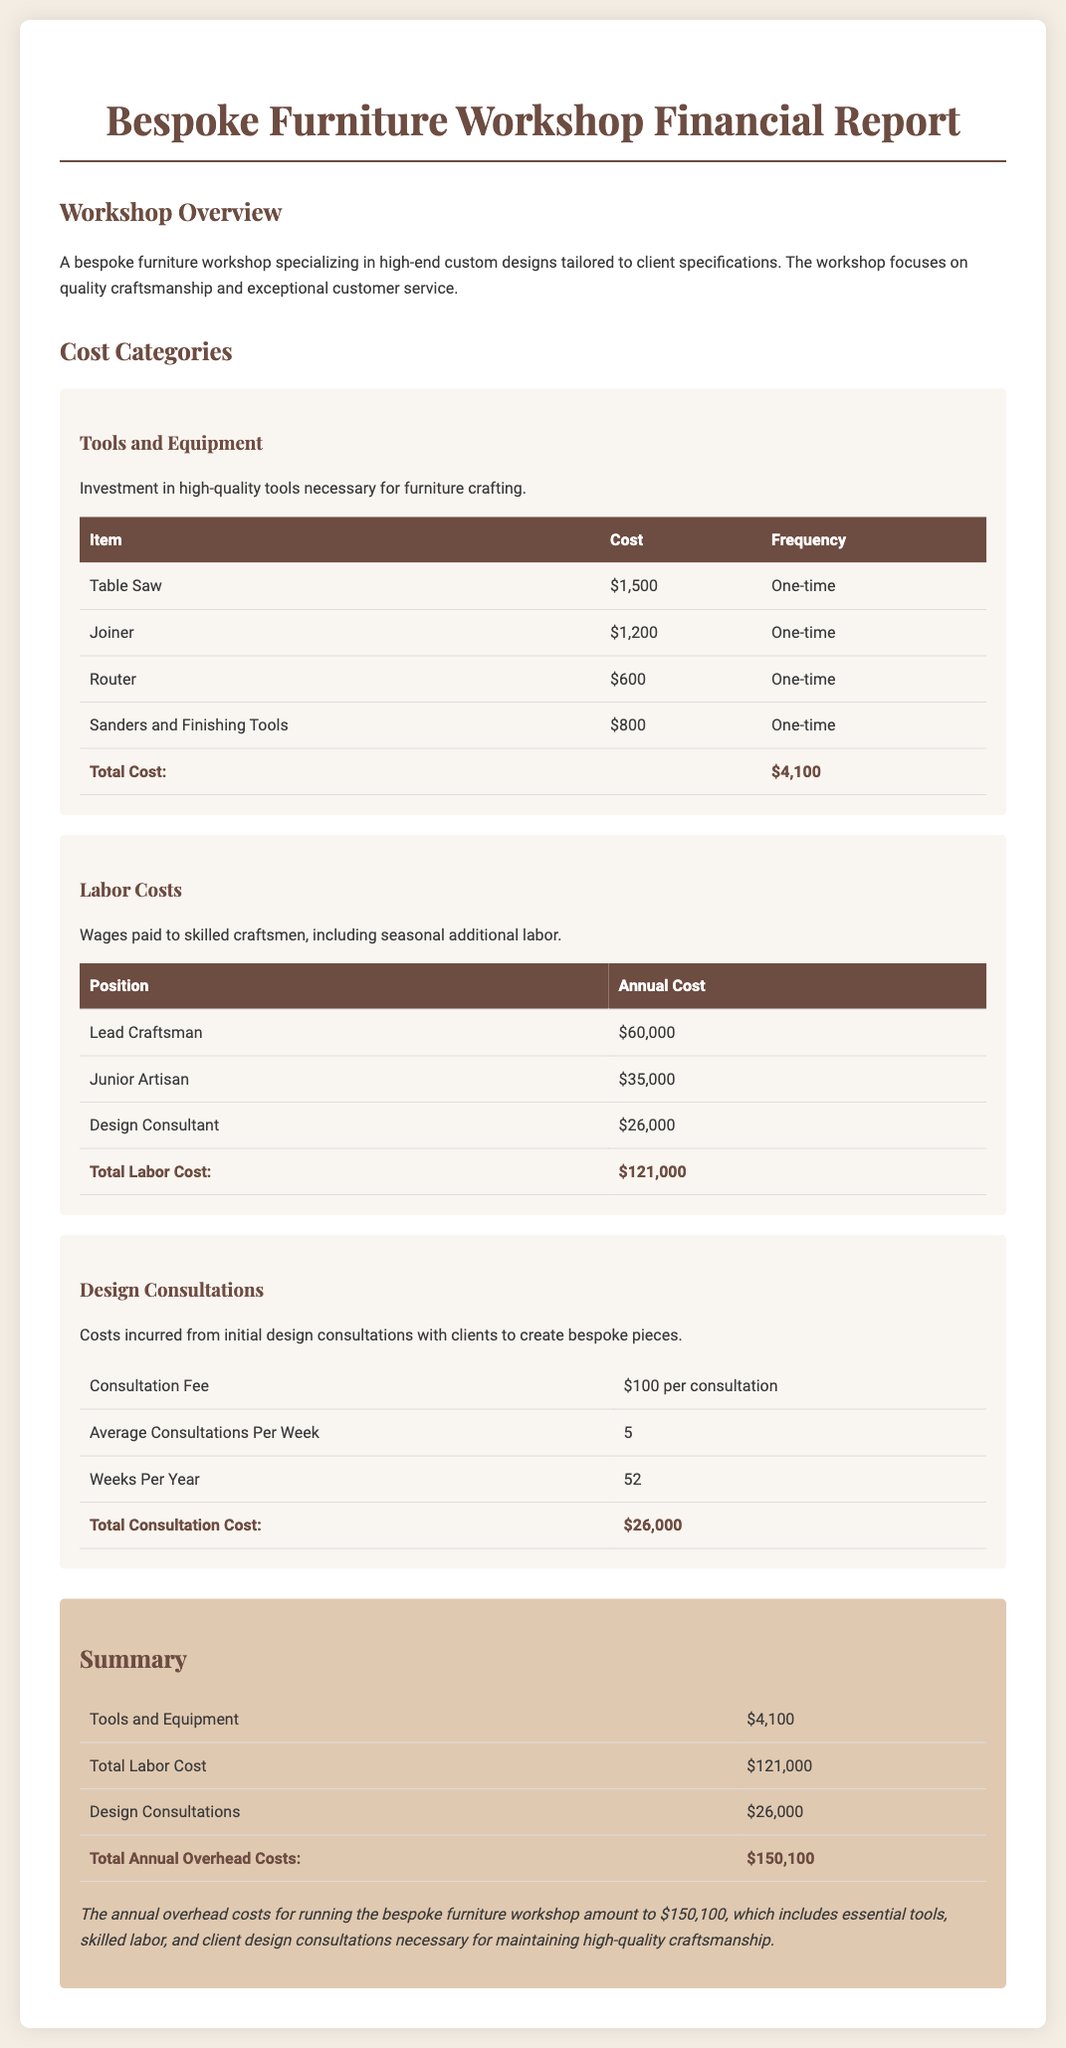What is the total cost of tools and equipment? The total cost of tools and equipment is listed in the respective table, which sums up to $4,100.
Answer: $4,100 What is the annual cost for the Lead Craftsman? The annual cost for the Lead Craftsman is specified in the labor costs section as $60,000.
Answer: $60,000 How many average consultations occur per week? The average consultations per week is indicated in the document as 5.
Answer: 5 What is the total annual overhead cost for the workshop? The total annual overhead cost is calculated in the summary section and amounts to $150,100.
Answer: $150,100 What is the cost of a consultation? The cost per consultation for design services is listed as $100.
Answer: $100 What is the total labor cost for the workshop? The document specifies the total labor cost as $121,000, which includes various positions.
Answer: $121,000 What type of furniture does the workshop specialize in? The workshop specializes in bespoke pieces, tailored to client specifications.
Answer: Bespoke pieces How much is spent on design consultations annually? The annual expenditure on design consultations is detailed in the report as $26,000.
Answer: $26,000 What is the frequency of tool costs listed in the report? The frequency of tool costs listed in the report is mainly "One-time" for each item.
Answer: One-time 